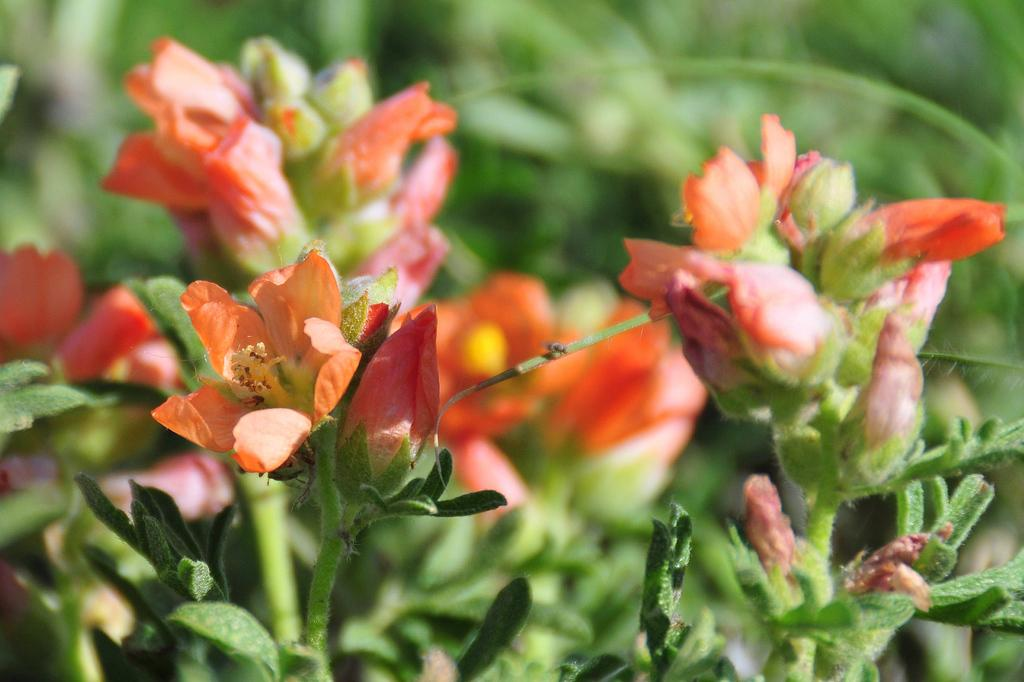What type of plants can be seen in the image? There are flower plants in the image. How would you describe the background of the image? The background of the image is blurred. What else can be seen in the background besides the blurred effect? Flowers and greenery are visible in the background. What type of nail is being used to measure the length of the flowers in the image? There is no nail or measuring activity present in the image; it features flower plants and a blurred background. 